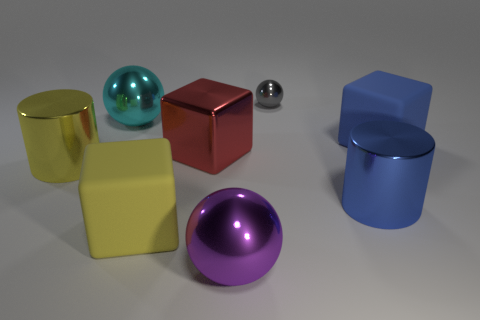What is the color of the other metallic cylinder that is the same size as the yellow metal cylinder?
Offer a terse response. Blue. How many large yellow metal objects are the same shape as the big blue rubber object?
Your answer should be very brief. 0. There is a yellow matte object; does it have the same size as the metal ball that is right of the big purple sphere?
Provide a succinct answer. No. There is a large metallic thing that is left of the large cyan shiny thing that is behind the big purple metallic ball; what shape is it?
Give a very brief answer. Cylinder. Are there fewer blue matte cubes that are left of the large purple metallic ball than tiny brown matte cylinders?
Provide a short and direct response. No. How many rubber blocks are the same size as the blue matte object?
Offer a terse response. 1. What is the shape of the large blue object that is behind the big red shiny cube?
Make the answer very short. Cube. Is the number of yellow things less than the number of large blocks?
Give a very brief answer. Yes. What size is the rubber thing in front of the yellow cylinder?
Give a very brief answer. Large. Is the number of big purple shiny spheres greater than the number of large shiny cylinders?
Give a very brief answer. No. 